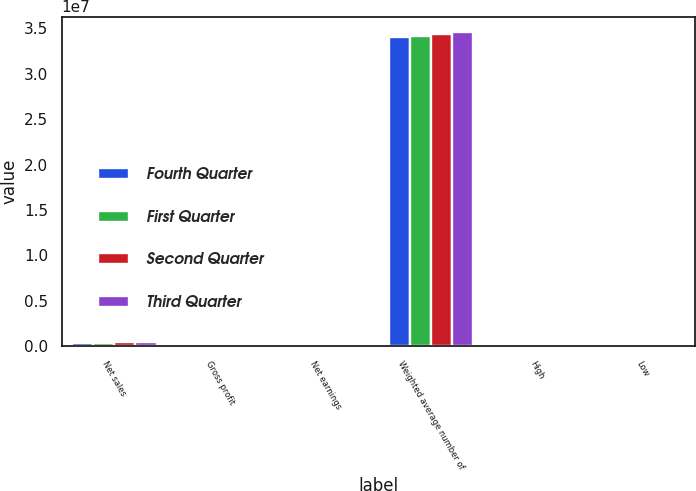Convert chart. <chart><loc_0><loc_0><loc_500><loc_500><stacked_bar_chart><ecel><fcel>Net sales<fcel>Gross profit<fcel>Net earnings<fcel>Weighted average number of<fcel>High<fcel>Low<nl><fcel>Fourth Quarter<fcel>374079<fcel>187922<fcel>33879<fcel>3.39963e+07<fcel>70.35<fcel>45.72<nl><fcel>First Quarter<fcel>407442<fcel>206234<fcel>27731<fcel>3.41926e+07<fcel>78.25<fcel>51.64<nl><fcel>Second Quarter<fcel>435650<fcel>225193<fcel>41545<fcel>3.44137e+07<fcel>92.92<fcel>75.33<nl><fcel>Third Quarter<fcel>511682<fcel>269988<fcel>69438<fcel>3.45606e+07<fcel>106.24<fcel>89.2<nl></chart> 